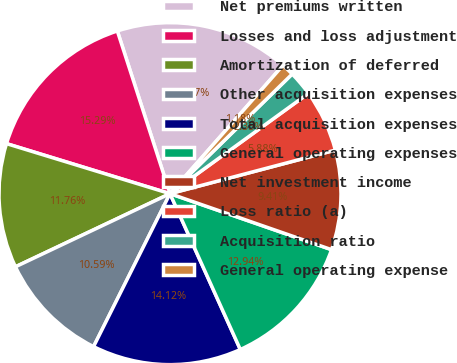Convert chart. <chart><loc_0><loc_0><loc_500><loc_500><pie_chart><fcel>Net premiums written<fcel>Losses and loss adjustment<fcel>Amortization of deferred<fcel>Other acquisition expenses<fcel>Total acquisition expenses<fcel>General operating expenses<fcel>Net investment income<fcel>Loss ratio (a)<fcel>Acquisition ratio<fcel>General operating expense<nl><fcel>16.47%<fcel>15.29%<fcel>11.76%<fcel>10.59%<fcel>14.12%<fcel>12.94%<fcel>9.41%<fcel>5.88%<fcel>2.35%<fcel>1.18%<nl></chart> 